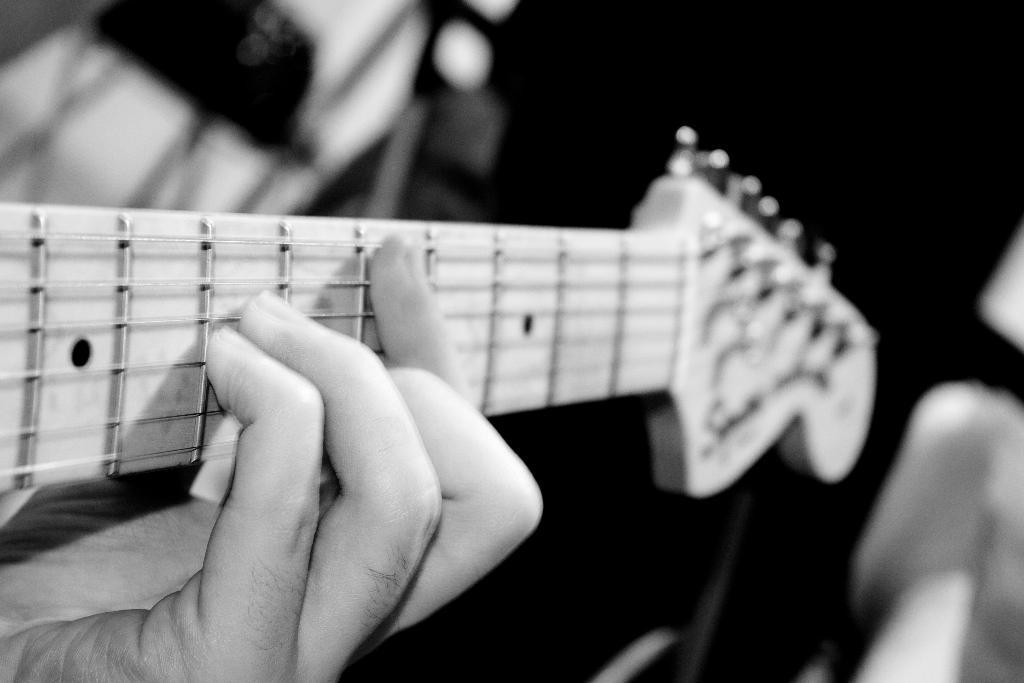How would you summarize this image in a sentence or two? This is a black and white image. In this image we can see a person playing a guitar. 